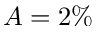Convert formula to latex. <formula><loc_0><loc_0><loc_500><loc_500>A = 2 \%</formula> 